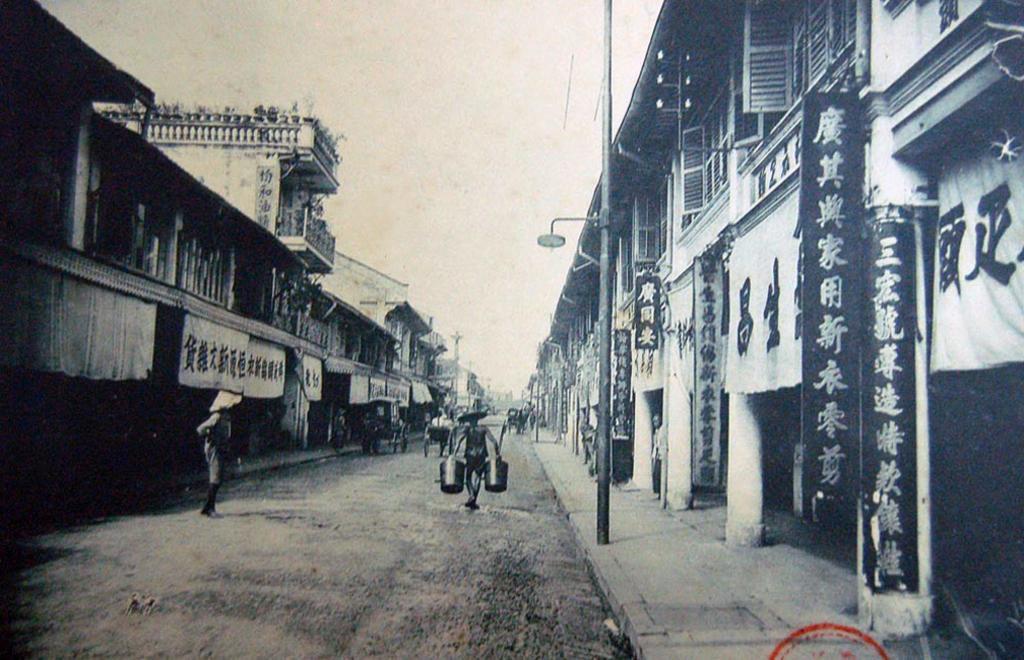Could you give a brief overview of what you see in this image? It is a black and white image. In this image we can see the buildings, hoardings and also banners. We can also see the light poles and some people on the road. Image also consists of the cart vehicles. At the top we can see the sky and we can also see the stamp on the right. 